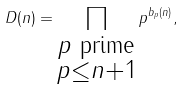<formula> <loc_0><loc_0><loc_500><loc_500>D ( n ) = \prod _ { \substack { { p \text { prime} } \\ p \leq n + 1 } } p ^ { b _ { p } ( n ) } ,</formula> 